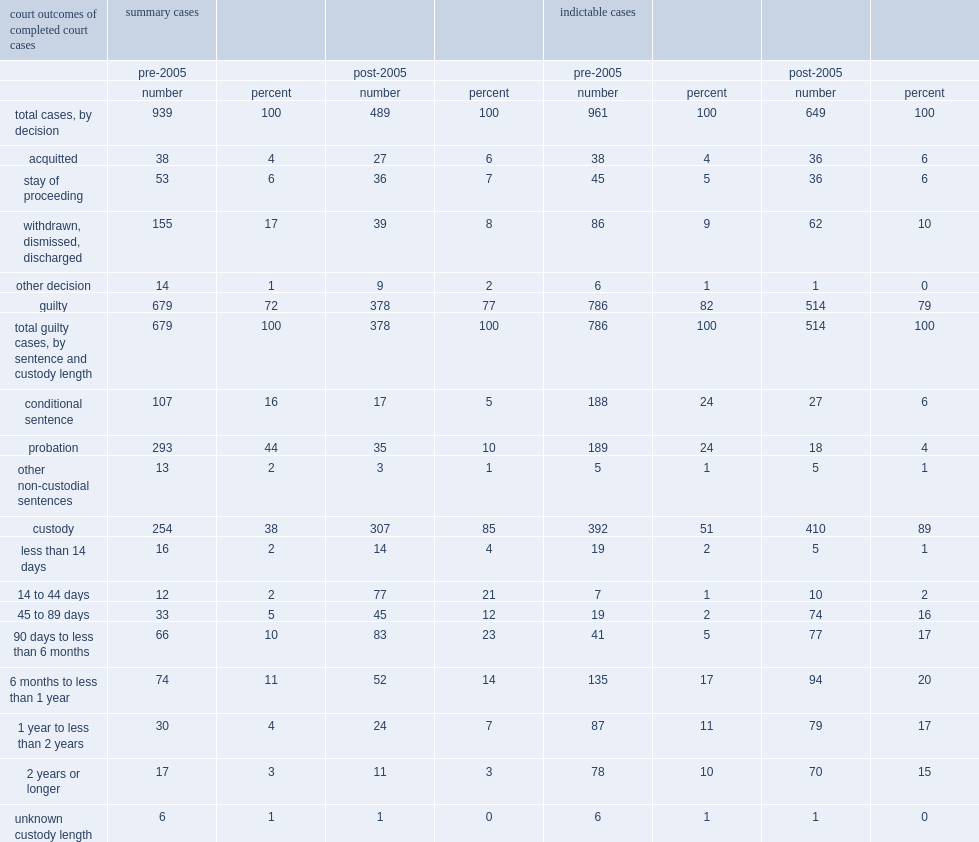What was the proportion of summary cases of the selected sexual violations against children resulting in a guilty finding pre 2005? 72.0. What was the proportion of summary cases of the selected sexual violations against children resulting in a guilty finding post 2005? 77.0. Which period has higher proportion of summary cases of the selected sexual violations against children resulting in a guilty finding, pre 2005 or post 2005? Post-2005. What was the proportion of custody sentences for guilty cases pre 2005? 38.0. What was the proportion of custody sentences for guilty cases post 2005? 85.0. Which period has higher proportion of custody senstences for guilty cases, pre 2005 or post 2005? Post-2005. 